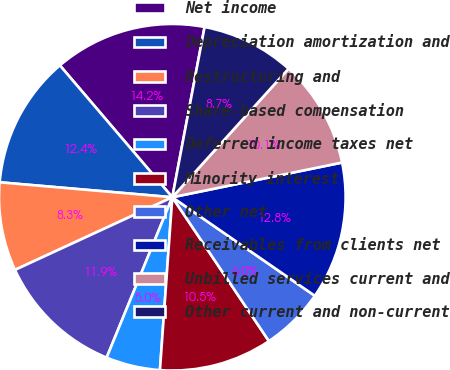Convert chart. <chart><loc_0><loc_0><loc_500><loc_500><pie_chart><fcel>Net income<fcel>Depreciation amortization and<fcel>Restructuring and<fcel>Share-based compensation<fcel>Deferred income taxes net<fcel>Minority interest<fcel>Other net<fcel>Receivables from clients net<fcel>Unbilled services current and<fcel>Other current and non-current<nl><fcel>14.22%<fcel>12.39%<fcel>8.26%<fcel>11.93%<fcel>5.05%<fcel>10.55%<fcel>5.96%<fcel>12.84%<fcel>10.09%<fcel>8.72%<nl></chart> 